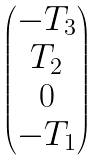<formula> <loc_0><loc_0><loc_500><loc_500>\begin{pmatrix} - T _ { 3 } \\ T _ { 2 } \\ 0 \\ - T _ { 1 } \end{pmatrix}</formula> 